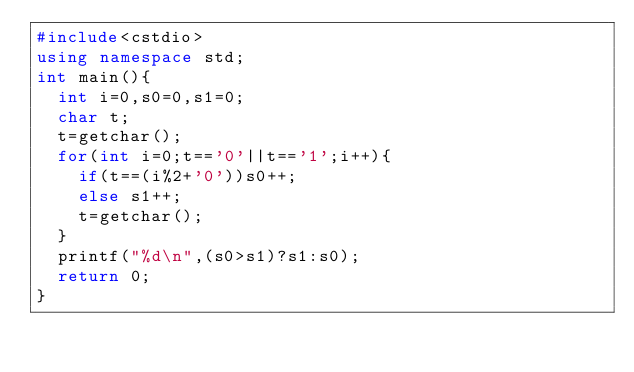<code> <loc_0><loc_0><loc_500><loc_500><_C++_>#include<cstdio>
using namespace std;
int main(){
  int i=0,s0=0,s1=0;
  char t;
  t=getchar();
  for(int i=0;t=='0'||t=='1';i++){
   	if(t==(i%2+'0'))s0++;
    else s1++;
    t=getchar();
  }
  printf("%d\n",(s0>s1)?s1:s0);
  return 0;
}</code> 